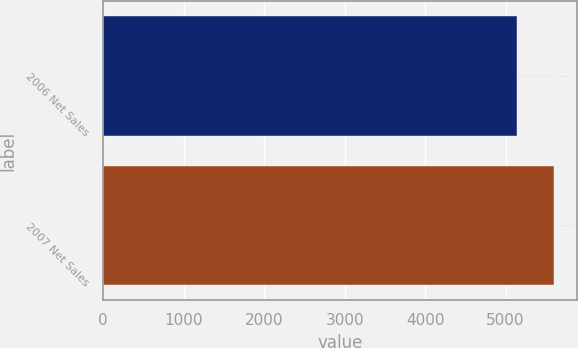Convert chart to OTSL. <chart><loc_0><loc_0><loc_500><loc_500><bar_chart><fcel>2006 Net Sales<fcel>2007 Net Sales<nl><fcel>5139<fcel>5607<nl></chart> 